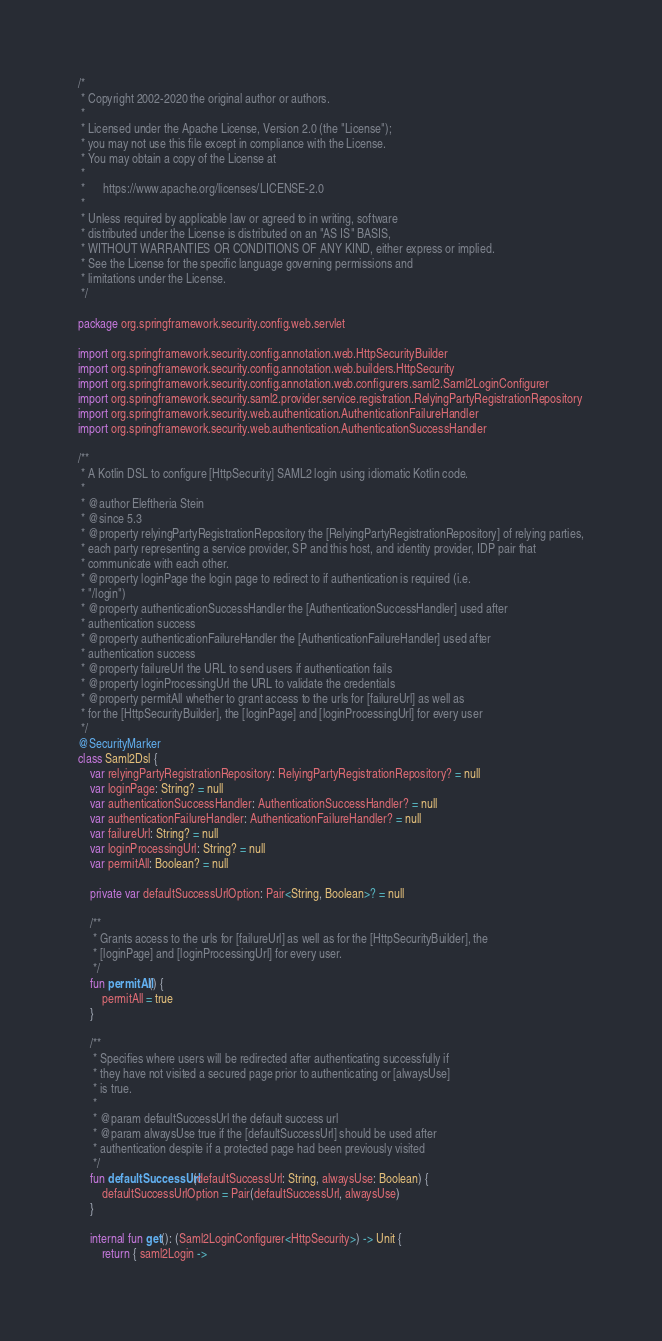<code> <loc_0><loc_0><loc_500><loc_500><_Kotlin_>/*
 * Copyright 2002-2020 the original author or authors.
 *
 * Licensed under the Apache License, Version 2.0 (the "License");
 * you may not use this file except in compliance with the License.
 * You may obtain a copy of the License at
 *
 *      https://www.apache.org/licenses/LICENSE-2.0
 *
 * Unless required by applicable law or agreed to in writing, software
 * distributed under the License is distributed on an "AS IS" BASIS,
 * WITHOUT WARRANTIES OR CONDITIONS OF ANY KIND, either express or implied.
 * See the License for the specific language governing permissions and
 * limitations under the License.
 */

package org.springframework.security.config.web.servlet

import org.springframework.security.config.annotation.web.HttpSecurityBuilder
import org.springframework.security.config.annotation.web.builders.HttpSecurity
import org.springframework.security.config.annotation.web.configurers.saml2.Saml2LoginConfigurer
import org.springframework.security.saml2.provider.service.registration.RelyingPartyRegistrationRepository
import org.springframework.security.web.authentication.AuthenticationFailureHandler
import org.springframework.security.web.authentication.AuthenticationSuccessHandler

/**
 * A Kotlin DSL to configure [HttpSecurity] SAML2 login using idiomatic Kotlin code.
 *
 * @author Eleftheria Stein
 * @since 5.3
 * @property relyingPartyRegistrationRepository the [RelyingPartyRegistrationRepository] of relying parties,
 * each party representing a service provider, SP and this host, and identity provider, IDP pair that
 * communicate with each other.
 * @property loginPage the login page to redirect to if authentication is required (i.e.
 * "/login")
 * @property authenticationSuccessHandler the [AuthenticationSuccessHandler] used after
 * authentication success
 * @property authenticationFailureHandler the [AuthenticationFailureHandler] used after
 * authentication success
 * @property failureUrl the URL to send users if authentication fails
 * @property loginProcessingUrl the URL to validate the credentials
 * @property permitAll whether to grant access to the urls for [failureUrl] as well as
 * for the [HttpSecurityBuilder], the [loginPage] and [loginProcessingUrl] for every user
 */
@SecurityMarker
class Saml2Dsl {
    var relyingPartyRegistrationRepository: RelyingPartyRegistrationRepository? = null
    var loginPage: String? = null
    var authenticationSuccessHandler: AuthenticationSuccessHandler? = null
    var authenticationFailureHandler: AuthenticationFailureHandler? = null
    var failureUrl: String? = null
    var loginProcessingUrl: String? = null
    var permitAll: Boolean? = null

    private var defaultSuccessUrlOption: Pair<String, Boolean>? = null

    /**
     * Grants access to the urls for [failureUrl] as well as for the [HttpSecurityBuilder], the
     * [loginPage] and [loginProcessingUrl] for every user.
     */
    fun permitAll() {
        permitAll = true
    }

    /**
     * Specifies where users will be redirected after authenticating successfully if
     * they have not visited a secured page prior to authenticating or [alwaysUse]
     * is true.
     *
     * @param defaultSuccessUrl the default success url
     * @param alwaysUse true if the [defaultSuccessUrl] should be used after
     * authentication despite if a protected page had been previously visited
     */
    fun defaultSuccessUrl(defaultSuccessUrl: String, alwaysUse: Boolean) {
        defaultSuccessUrlOption = Pair(defaultSuccessUrl, alwaysUse)
    }

    internal fun get(): (Saml2LoginConfigurer<HttpSecurity>) -> Unit {
        return { saml2Login -></code> 